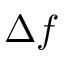Convert formula to latex. <formula><loc_0><loc_0><loc_500><loc_500>\Delta f</formula> 